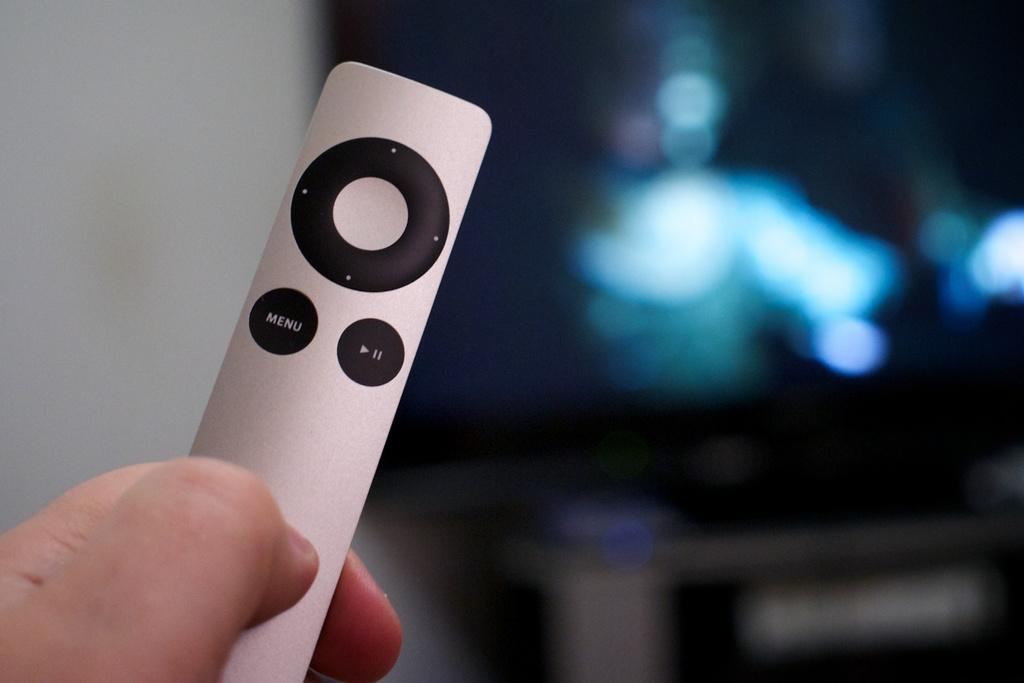<image>
Provide a brief description of the given image. Someone is holding a tiny silver remote with a menu button on it. 